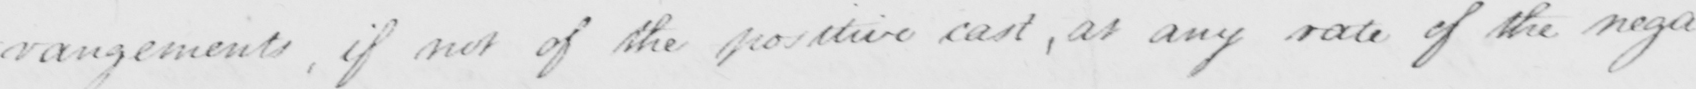Can you tell me what this handwritten text says? -rangements, if not of the positive cast, at any rate of the negative 